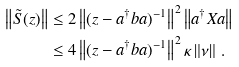<formula> <loc_0><loc_0><loc_500><loc_500>\left \| \tilde { S } ( z ) \right \| & \leq 2 \left \| ( z - a ^ { \dagger } b a ) ^ { - 1 } \right \| ^ { 2 } \left \| a ^ { \dagger } X a \right \| \\ & \leq 4 \left \| ( z - a ^ { \dagger } b a ) ^ { - 1 } \right \| ^ { 2 } \kappa \left \| \nu \right \| \, .</formula> 